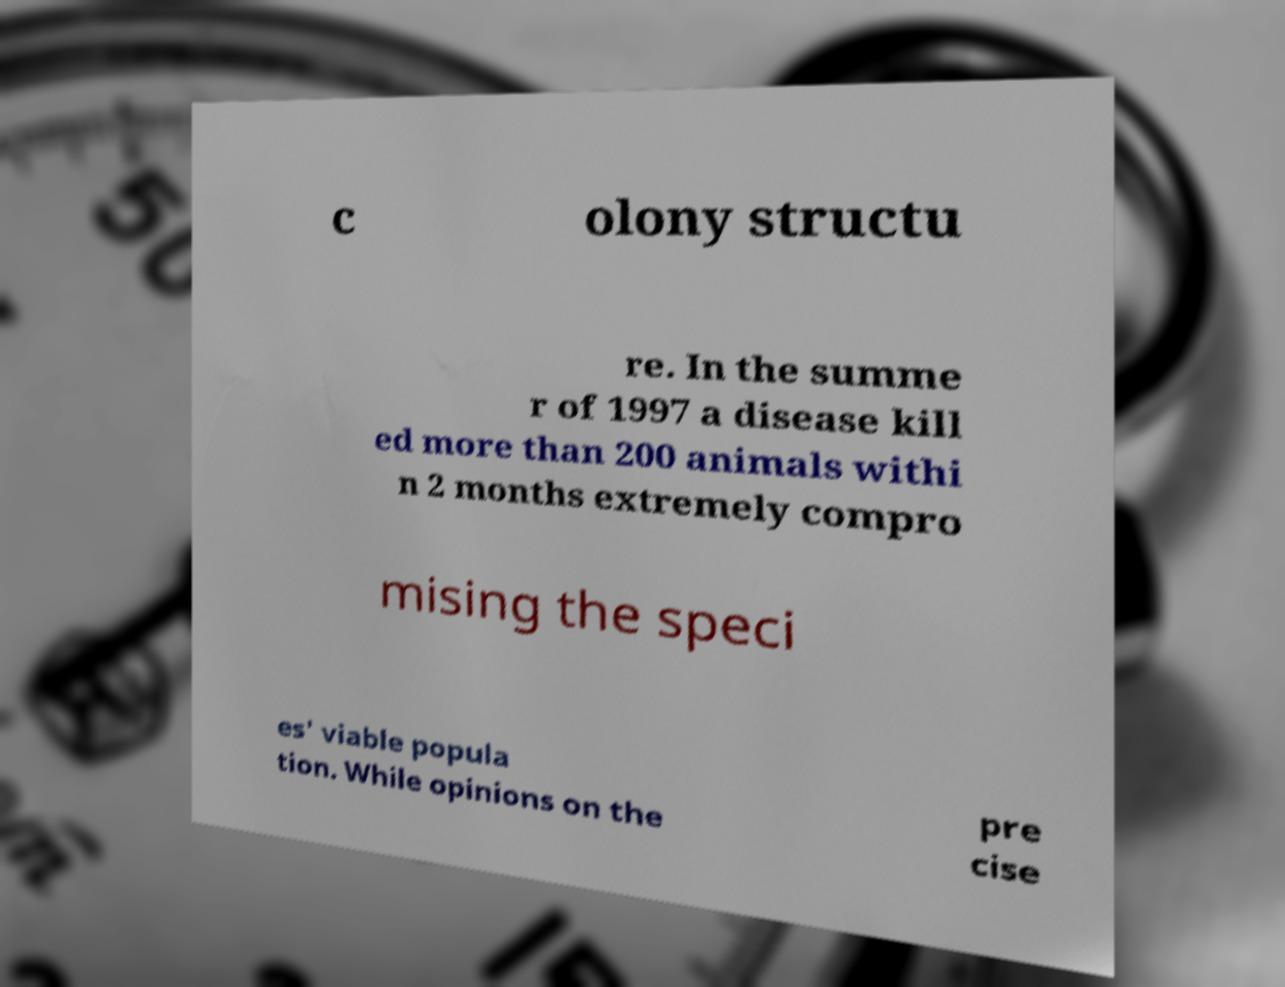Can you read and provide the text displayed in the image?This photo seems to have some interesting text. Can you extract and type it out for me? c olony structu re. In the summe r of 1997 a disease kill ed more than 200 animals withi n 2 months extremely compro mising the speci es' viable popula tion. While opinions on the pre cise 